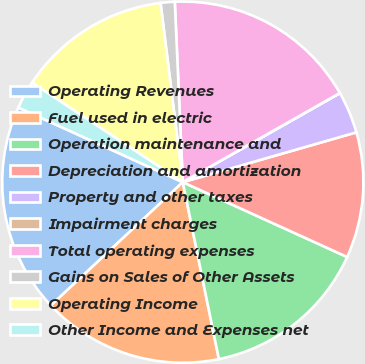Convert chart. <chart><loc_0><loc_0><loc_500><loc_500><pie_chart><fcel>Operating Revenues<fcel>Fuel used in electric<fcel>Operation maintenance and<fcel>Depreciation and amortization<fcel>Property and other taxes<fcel>Impairment charges<fcel>Total operating expenses<fcel>Gains on Sales of Other Assets<fcel>Operating Income<fcel>Other Income and Expenses net<nl><fcel>18.74%<fcel>16.24%<fcel>15.0%<fcel>11.25%<fcel>3.76%<fcel>0.01%<fcel>17.49%<fcel>1.26%<fcel>13.75%<fcel>2.51%<nl></chart> 